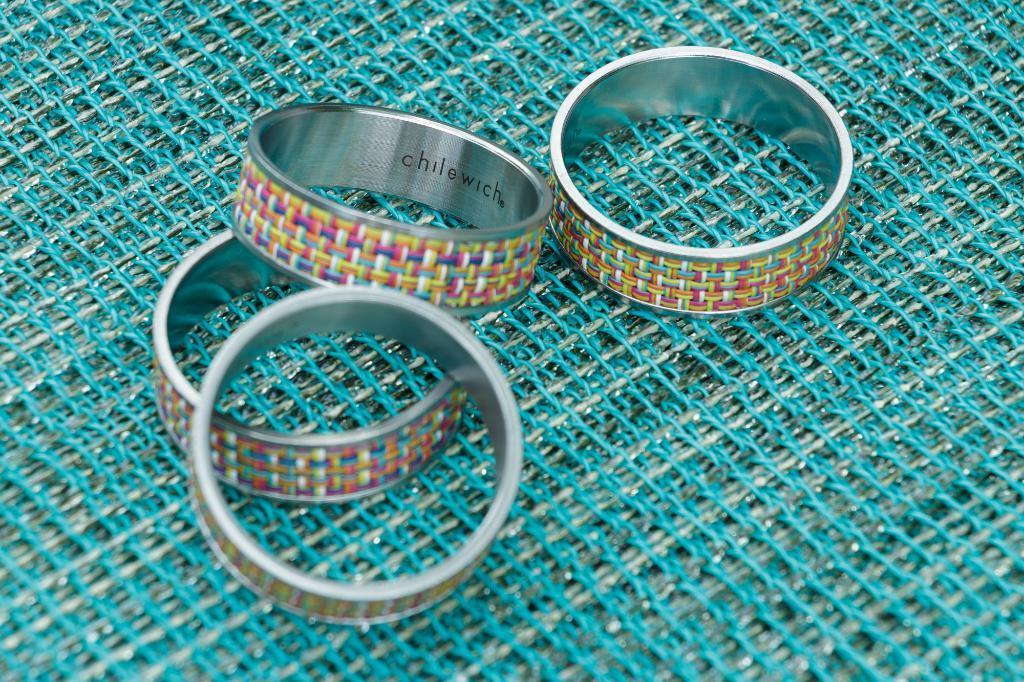Could you give a brief overview of what you see in this image? In this image, I can see four finger rings, which are placed on a mesh. 